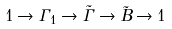Convert formula to latex. <formula><loc_0><loc_0><loc_500><loc_500>1 \rightarrow \Gamma _ { 1 } \rightarrow \tilde { \Gamma } \rightarrow \tilde { B } \rightarrow 1</formula> 